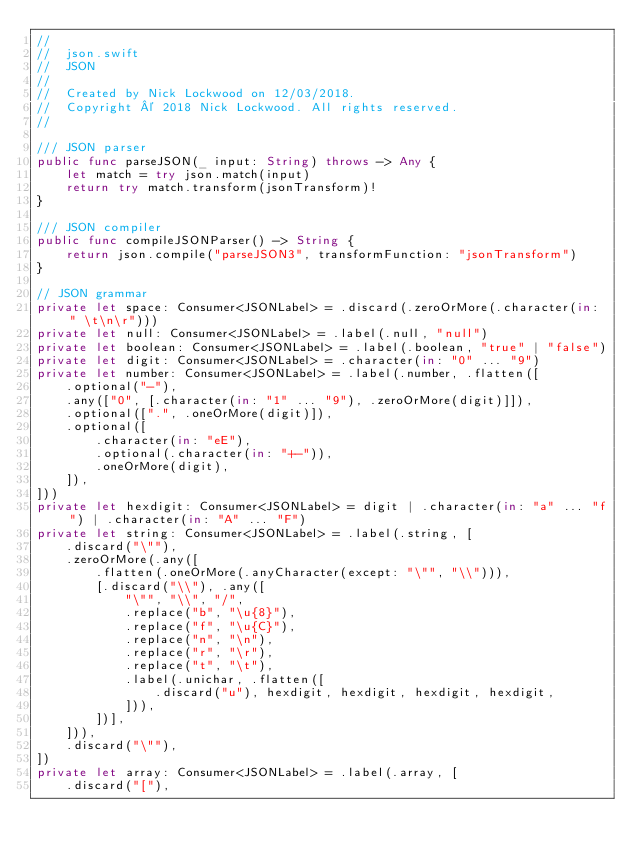Convert code to text. <code><loc_0><loc_0><loc_500><loc_500><_Swift_>//
//  json.swift
//  JSON
//
//  Created by Nick Lockwood on 12/03/2018.
//  Copyright © 2018 Nick Lockwood. All rights reserved.
//

/// JSON parser
public func parseJSON(_ input: String) throws -> Any {
    let match = try json.match(input)
    return try match.transform(jsonTransform)!
}

/// JSON compiler
public func compileJSONParser() -> String {
    return json.compile("parseJSON3", transformFunction: "jsonTransform")
}

// JSON grammar
private let space: Consumer<JSONLabel> = .discard(.zeroOrMore(.character(in: " \t\n\r")))
private let null: Consumer<JSONLabel> = .label(.null, "null")
private let boolean: Consumer<JSONLabel> = .label(.boolean, "true" | "false")
private let digit: Consumer<JSONLabel> = .character(in: "0" ... "9")
private let number: Consumer<JSONLabel> = .label(.number, .flatten([
    .optional("-"),
    .any(["0", [.character(in: "1" ... "9"), .zeroOrMore(digit)]]),
    .optional([".", .oneOrMore(digit)]),
    .optional([
        .character(in: "eE"),
        .optional(.character(in: "+-")),
        .oneOrMore(digit),
    ]),
]))
private let hexdigit: Consumer<JSONLabel> = digit | .character(in: "a" ... "f") | .character(in: "A" ... "F")
private let string: Consumer<JSONLabel> = .label(.string, [
    .discard("\""),
    .zeroOrMore(.any([
        .flatten(.oneOrMore(.anyCharacter(except: "\"", "\\"))),
        [.discard("\\"), .any([
            "\"", "\\", "/",
            .replace("b", "\u{8}"),
            .replace("f", "\u{C}"),
            .replace("n", "\n"),
            .replace("r", "\r"),
            .replace("t", "\t"),
            .label(.unichar, .flatten([
                .discard("u"), hexdigit, hexdigit, hexdigit, hexdigit,
            ])),
        ])],
    ])),
    .discard("\""),
])
private let array: Consumer<JSONLabel> = .label(.array, [
    .discard("["),</code> 